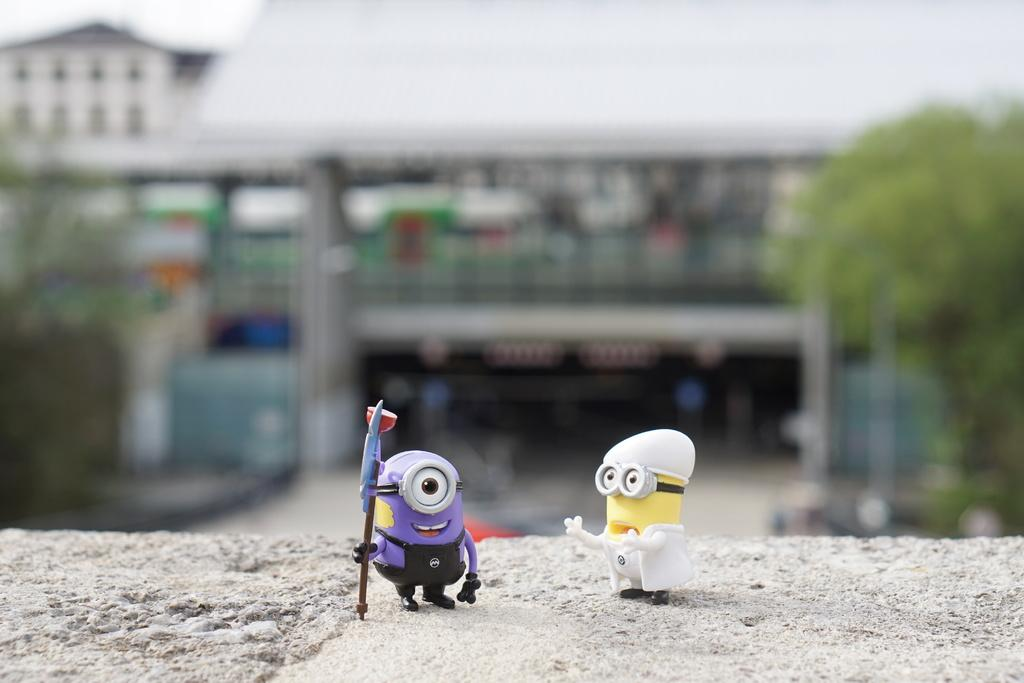How many toys can be seen in the image? There are two toys in the image. What is the color of the surface on which the toys are placed? The toys are on a grey color surface. What can be seen in the background of the image? There are trees and buildings in the background of the image. How many ladybugs are crawling on the toys in the image? There are no ladybugs present in the image; it only features two toys on a grey surface with a background of trees and buildings. 